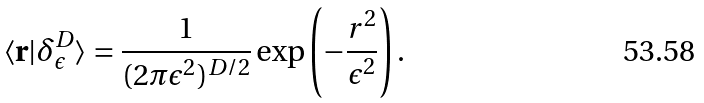Convert formula to latex. <formula><loc_0><loc_0><loc_500><loc_500>\langle { \mathbf r } | \delta _ { \epsilon } ^ { D } \rangle = \frac { 1 } { ( 2 \pi \epsilon ^ { 2 } ) ^ { D / 2 } } \exp \left ( - \frac { r ^ { 2 } } { \epsilon ^ { 2 } } \right ) .</formula> 